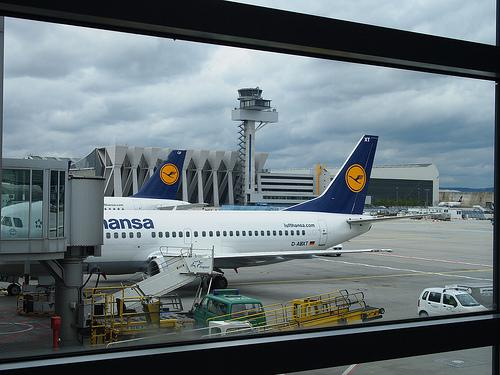Question: what color is the plane?
Choices:
A. Silver.
B. Black.
C. White.
D. Blue.
Answer with the letter. Answer: C 